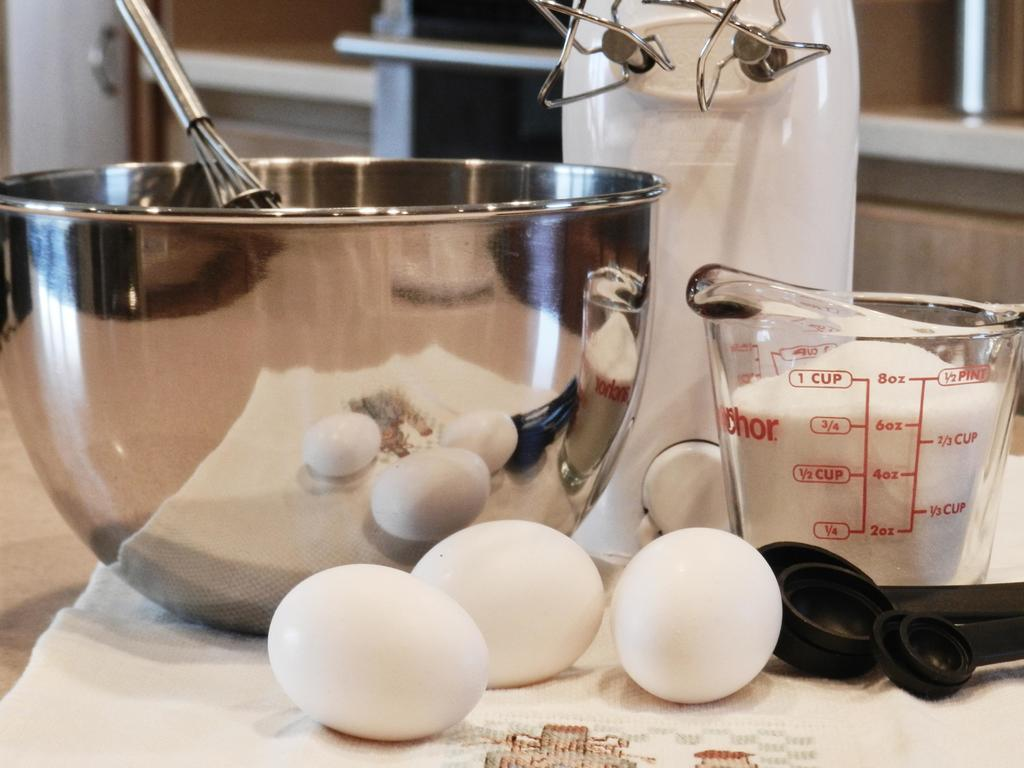<image>
Describe the image concisely. A measuring cup with a brand name then ends with chor sits next to a stand mixer. 